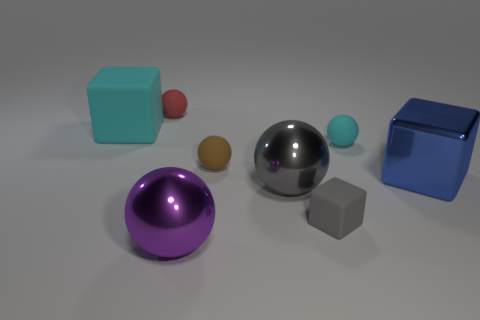Subtract all purple spheres. How many spheres are left? 4 Subtract all brown rubber balls. How many balls are left? 4 Subtract all yellow spheres. Subtract all purple blocks. How many spheres are left? 5 Add 2 matte blocks. How many objects exist? 10 Subtract all spheres. How many objects are left? 3 Add 7 large purple things. How many large purple things are left? 8 Add 1 large blue blocks. How many large blue blocks exist? 2 Subtract 1 blue blocks. How many objects are left? 7 Subtract all purple shiny things. Subtract all gray objects. How many objects are left? 5 